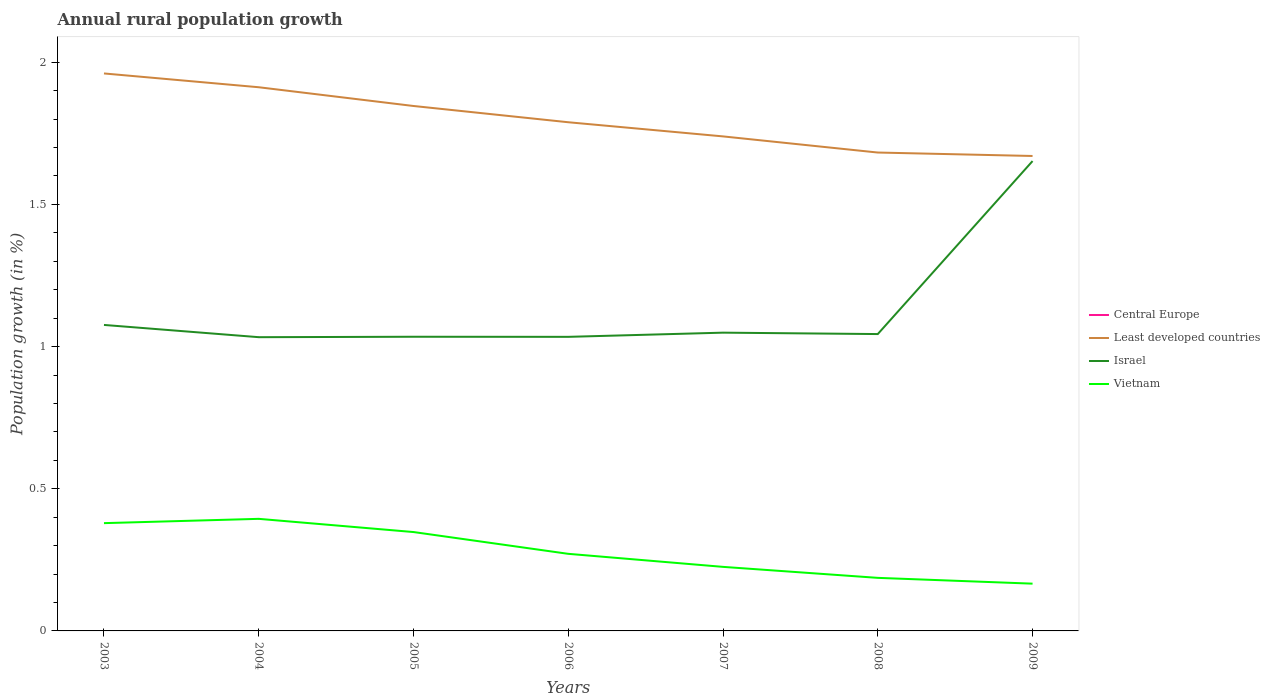Is the number of lines equal to the number of legend labels?
Your answer should be very brief. No. What is the total percentage of rural population growth in Vietnam in the graph?
Your answer should be very brief. 0.08. What is the difference between the highest and the second highest percentage of rural population growth in Israel?
Your answer should be very brief. 0.62. Is the percentage of rural population growth in Israel strictly greater than the percentage of rural population growth in Vietnam over the years?
Make the answer very short. No. How many lines are there?
Give a very brief answer. 3. How many years are there in the graph?
Your answer should be very brief. 7. Does the graph contain any zero values?
Your response must be concise. Yes. Where does the legend appear in the graph?
Your response must be concise. Center right. How are the legend labels stacked?
Provide a succinct answer. Vertical. What is the title of the graph?
Ensure brevity in your answer.  Annual rural population growth. What is the label or title of the X-axis?
Your answer should be compact. Years. What is the label or title of the Y-axis?
Provide a short and direct response. Population growth (in %). What is the Population growth (in %) in Central Europe in 2003?
Keep it short and to the point. 0. What is the Population growth (in %) of Least developed countries in 2003?
Offer a terse response. 1.96. What is the Population growth (in %) of Israel in 2003?
Your answer should be compact. 1.08. What is the Population growth (in %) in Vietnam in 2003?
Ensure brevity in your answer.  0.38. What is the Population growth (in %) in Central Europe in 2004?
Keep it short and to the point. 0. What is the Population growth (in %) of Least developed countries in 2004?
Provide a succinct answer. 1.91. What is the Population growth (in %) of Israel in 2004?
Offer a terse response. 1.03. What is the Population growth (in %) of Vietnam in 2004?
Your answer should be very brief. 0.39. What is the Population growth (in %) of Least developed countries in 2005?
Your answer should be compact. 1.85. What is the Population growth (in %) in Israel in 2005?
Keep it short and to the point. 1.03. What is the Population growth (in %) of Vietnam in 2005?
Provide a short and direct response. 0.35. What is the Population growth (in %) of Least developed countries in 2006?
Give a very brief answer. 1.79. What is the Population growth (in %) of Israel in 2006?
Provide a short and direct response. 1.03. What is the Population growth (in %) of Vietnam in 2006?
Make the answer very short. 0.27. What is the Population growth (in %) of Central Europe in 2007?
Provide a succinct answer. 0. What is the Population growth (in %) in Least developed countries in 2007?
Ensure brevity in your answer.  1.74. What is the Population growth (in %) of Israel in 2007?
Your response must be concise. 1.05. What is the Population growth (in %) of Vietnam in 2007?
Keep it short and to the point. 0.23. What is the Population growth (in %) of Central Europe in 2008?
Provide a short and direct response. 0. What is the Population growth (in %) in Least developed countries in 2008?
Offer a terse response. 1.68. What is the Population growth (in %) in Israel in 2008?
Your answer should be compact. 1.04. What is the Population growth (in %) of Vietnam in 2008?
Provide a succinct answer. 0.19. What is the Population growth (in %) in Least developed countries in 2009?
Offer a terse response. 1.67. What is the Population growth (in %) in Israel in 2009?
Ensure brevity in your answer.  1.65. What is the Population growth (in %) of Vietnam in 2009?
Give a very brief answer. 0.17. Across all years, what is the maximum Population growth (in %) of Least developed countries?
Offer a terse response. 1.96. Across all years, what is the maximum Population growth (in %) of Israel?
Keep it short and to the point. 1.65. Across all years, what is the maximum Population growth (in %) of Vietnam?
Your answer should be very brief. 0.39. Across all years, what is the minimum Population growth (in %) of Least developed countries?
Offer a terse response. 1.67. Across all years, what is the minimum Population growth (in %) in Israel?
Provide a short and direct response. 1.03. Across all years, what is the minimum Population growth (in %) in Vietnam?
Your response must be concise. 0.17. What is the total Population growth (in %) of Central Europe in the graph?
Provide a short and direct response. 0. What is the total Population growth (in %) of Least developed countries in the graph?
Offer a terse response. 12.6. What is the total Population growth (in %) of Israel in the graph?
Offer a very short reply. 7.92. What is the total Population growth (in %) of Vietnam in the graph?
Give a very brief answer. 1.97. What is the difference between the Population growth (in %) in Least developed countries in 2003 and that in 2004?
Give a very brief answer. 0.05. What is the difference between the Population growth (in %) in Israel in 2003 and that in 2004?
Make the answer very short. 0.04. What is the difference between the Population growth (in %) in Vietnam in 2003 and that in 2004?
Ensure brevity in your answer.  -0.02. What is the difference between the Population growth (in %) of Least developed countries in 2003 and that in 2005?
Make the answer very short. 0.11. What is the difference between the Population growth (in %) of Israel in 2003 and that in 2005?
Provide a short and direct response. 0.04. What is the difference between the Population growth (in %) in Vietnam in 2003 and that in 2005?
Give a very brief answer. 0.03. What is the difference between the Population growth (in %) in Least developed countries in 2003 and that in 2006?
Your answer should be very brief. 0.17. What is the difference between the Population growth (in %) of Israel in 2003 and that in 2006?
Your answer should be compact. 0.04. What is the difference between the Population growth (in %) in Vietnam in 2003 and that in 2006?
Keep it short and to the point. 0.11. What is the difference between the Population growth (in %) of Least developed countries in 2003 and that in 2007?
Make the answer very short. 0.22. What is the difference between the Population growth (in %) in Israel in 2003 and that in 2007?
Your answer should be compact. 0.03. What is the difference between the Population growth (in %) in Vietnam in 2003 and that in 2007?
Provide a succinct answer. 0.15. What is the difference between the Population growth (in %) of Least developed countries in 2003 and that in 2008?
Keep it short and to the point. 0.28. What is the difference between the Population growth (in %) of Israel in 2003 and that in 2008?
Provide a short and direct response. 0.03. What is the difference between the Population growth (in %) of Vietnam in 2003 and that in 2008?
Provide a short and direct response. 0.19. What is the difference between the Population growth (in %) of Least developed countries in 2003 and that in 2009?
Keep it short and to the point. 0.29. What is the difference between the Population growth (in %) in Israel in 2003 and that in 2009?
Offer a very short reply. -0.58. What is the difference between the Population growth (in %) of Vietnam in 2003 and that in 2009?
Your answer should be compact. 0.21. What is the difference between the Population growth (in %) in Least developed countries in 2004 and that in 2005?
Your answer should be compact. 0.07. What is the difference between the Population growth (in %) of Israel in 2004 and that in 2005?
Offer a very short reply. -0. What is the difference between the Population growth (in %) of Vietnam in 2004 and that in 2005?
Your response must be concise. 0.05. What is the difference between the Population growth (in %) of Least developed countries in 2004 and that in 2006?
Keep it short and to the point. 0.12. What is the difference between the Population growth (in %) in Israel in 2004 and that in 2006?
Ensure brevity in your answer.  -0. What is the difference between the Population growth (in %) in Vietnam in 2004 and that in 2006?
Your answer should be very brief. 0.12. What is the difference between the Population growth (in %) in Least developed countries in 2004 and that in 2007?
Give a very brief answer. 0.17. What is the difference between the Population growth (in %) of Israel in 2004 and that in 2007?
Provide a short and direct response. -0.02. What is the difference between the Population growth (in %) of Vietnam in 2004 and that in 2007?
Ensure brevity in your answer.  0.17. What is the difference between the Population growth (in %) of Least developed countries in 2004 and that in 2008?
Provide a succinct answer. 0.23. What is the difference between the Population growth (in %) of Israel in 2004 and that in 2008?
Your response must be concise. -0.01. What is the difference between the Population growth (in %) of Vietnam in 2004 and that in 2008?
Keep it short and to the point. 0.21. What is the difference between the Population growth (in %) of Least developed countries in 2004 and that in 2009?
Offer a terse response. 0.24. What is the difference between the Population growth (in %) in Israel in 2004 and that in 2009?
Give a very brief answer. -0.62. What is the difference between the Population growth (in %) in Vietnam in 2004 and that in 2009?
Provide a succinct answer. 0.23. What is the difference between the Population growth (in %) of Least developed countries in 2005 and that in 2006?
Ensure brevity in your answer.  0.06. What is the difference between the Population growth (in %) in Vietnam in 2005 and that in 2006?
Keep it short and to the point. 0.08. What is the difference between the Population growth (in %) of Least developed countries in 2005 and that in 2007?
Provide a succinct answer. 0.11. What is the difference between the Population growth (in %) in Israel in 2005 and that in 2007?
Offer a terse response. -0.01. What is the difference between the Population growth (in %) of Vietnam in 2005 and that in 2007?
Your answer should be very brief. 0.12. What is the difference between the Population growth (in %) in Least developed countries in 2005 and that in 2008?
Your answer should be compact. 0.16. What is the difference between the Population growth (in %) of Israel in 2005 and that in 2008?
Your answer should be compact. -0.01. What is the difference between the Population growth (in %) in Vietnam in 2005 and that in 2008?
Your response must be concise. 0.16. What is the difference between the Population growth (in %) of Least developed countries in 2005 and that in 2009?
Ensure brevity in your answer.  0.18. What is the difference between the Population growth (in %) of Israel in 2005 and that in 2009?
Offer a very short reply. -0.62. What is the difference between the Population growth (in %) in Vietnam in 2005 and that in 2009?
Keep it short and to the point. 0.18. What is the difference between the Population growth (in %) in Least developed countries in 2006 and that in 2007?
Your response must be concise. 0.05. What is the difference between the Population growth (in %) in Israel in 2006 and that in 2007?
Keep it short and to the point. -0.01. What is the difference between the Population growth (in %) of Vietnam in 2006 and that in 2007?
Your answer should be compact. 0.05. What is the difference between the Population growth (in %) of Least developed countries in 2006 and that in 2008?
Ensure brevity in your answer.  0.11. What is the difference between the Population growth (in %) in Israel in 2006 and that in 2008?
Your answer should be very brief. -0.01. What is the difference between the Population growth (in %) in Vietnam in 2006 and that in 2008?
Make the answer very short. 0.08. What is the difference between the Population growth (in %) in Least developed countries in 2006 and that in 2009?
Provide a succinct answer. 0.12. What is the difference between the Population growth (in %) of Israel in 2006 and that in 2009?
Make the answer very short. -0.62. What is the difference between the Population growth (in %) of Vietnam in 2006 and that in 2009?
Keep it short and to the point. 0.1. What is the difference between the Population growth (in %) in Least developed countries in 2007 and that in 2008?
Ensure brevity in your answer.  0.06. What is the difference between the Population growth (in %) of Israel in 2007 and that in 2008?
Provide a succinct answer. 0.01. What is the difference between the Population growth (in %) in Vietnam in 2007 and that in 2008?
Make the answer very short. 0.04. What is the difference between the Population growth (in %) of Least developed countries in 2007 and that in 2009?
Your answer should be very brief. 0.07. What is the difference between the Population growth (in %) in Israel in 2007 and that in 2009?
Your response must be concise. -0.6. What is the difference between the Population growth (in %) in Vietnam in 2007 and that in 2009?
Your answer should be very brief. 0.06. What is the difference between the Population growth (in %) in Least developed countries in 2008 and that in 2009?
Your answer should be very brief. 0.01. What is the difference between the Population growth (in %) of Israel in 2008 and that in 2009?
Your answer should be very brief. -0.61. What is the difference between the Population growth (in %) in Vietnam in 2008 and that in 2009?
Offer a very short reply. 0.02. What is the difference between the Population growth (in %) in Least developed countries in 2003 and the Population growth (in %) in Israel in 2004?
Your answer should be very brief. 0.93. What is the difference between the Population growth (in %) of Least developed countries in 2003 and the Population growth (in %) of Vietnam in 2004?
Give a very brief answer. 1.57. What is the difference between the Population growth (in %) of Israel in 2003 and the Population growth (in %) of Vietnam in 2004?
Your answer should be very brief. 0.68. What is the difference between the Population growth (in %) in Least developed countries in 2003 and the Population growth (in %) in Israel in 2005?
Offer a terse response. 0.93. What is the difference between the Population growth (in %) of Least developed countries in 2003 and the Population growth (in %) of Vietnam in 2005?
Provide a succinct answer. 1.61. What is the difference between the Population growth (in %) of Israel in 2003 and the Population growth (in %) of Vietnam in 2005?
Your answer should be compact. 0.73. What is the difference between the Population growth (in %) of Least developed countries in 2003 and the Population growth (in %) of Israel in 2006?
Make the answer very short. 0.93. What is the difference between the Population growth (in %) in Least developed countries in 2003 and the Population growth (in %) in Vietnam in 2006?
Give a very brief answer. 1.69. What is the difference between the Population growth (in %) in Israel in 2003 and the Population growth (in %) in Vietnam in 2006?
Ensure brevity in your answer.  0.81. What is the difference between the Population growth (in %) in Least developed countries in 2003 and the Population growth (in %) in Israel in 2007?
Offer a terse response. 0.91. What is the difference between the Population growth (in %) of Least developed countries in 2003 and the Population growth (in %) of Vietnam in 2007?
Keep it short and to the point. 1.74. What is the difference between the Population growth (in %) in Israel in 2003 and the Population growth (in %) in Vietnam in 2007?
Provide a short and direct response. 0.85. What is the difference between the Population growth (in %) of Least developed countries in 2003 and the Population growth (in %) of Israel in 2008?
Your answer should be very brief. 0.92. What is the difference between the Population growth (in %) of Least developed countries in 2003 and the Population growth (in %) of Vietnam in 2008?
Your answer should be compact. 1.77. What is the difference between the Population growth (in %) of Israel in 2003 and the Population growth (in %) of Vietnam in 2008?
Give a very brief answer. 0.89. What is the difference between the Population growth (in %) of Least developed countries in 2003 and the Population growth (in %) of Israel in 2009?
Ensure brevity in your answer.  0.31. What is the difference between the Population growth (in %) in Least developed countries in 2003 and the Population growth (in %) in Vietnam in 2009?
Your response must be concise. 1.79. What is the difference between the Population growth (in %) of Israel in 2003 and the Population growth (in %) of Vietnam in 2009?
Offer a very short reply. 0.91. What is the difference between the Population growth (in %) of Least developed countries in 2004 and the Population growth (in %) of Israel in 2005?
Offer a very short reply. 0.88. What is the difference between the Population growth (in %) of Least developed countries in 2004 and the Population growth (in %) of Vietnam in 2005?
Offer a very short reply. 1.56. What is the difference between the Population growth (in %) of Israel in 2004 and the Population growth (in %) of Vietnam in 2005?
Give a very brief answer. 0.69. What is the difference between the Population growth (in %) of Least developed countries in 2004 and the Population growth (in %) of Israel in 2006?
Offer a very short reply. 0.88. What is the difference between the Population growth (in %) in Least developed countries in 2004 and the Population growth (in %) in Vietnam in 2006?
Your answer should be very brief. 1.64. What is the difference between the Population growth (in %) in Israel in 2004 and the Population growth (in %) in Vietnam in 2006?
Keep it short and to the point. 0.76. What is the difference between the Population growth (in %) of Least developed countries in 2004 and the Population growth (in %) of Israel in 2007?
Keep it short and to the point. 0.86. What is the difference between the Population growth (in %) in Least developed countries in 2004 and the Population growth (in %) in Vietnam in 2007?
Offer a terse response. 1.69. What is the difference between the Population growth (in %) in Israel in 2004 and the Population growth (in %) in Vietnam in 2007?
Give a very brief answer. 0.81. What is the difference between the Population growth (in %) in Least developed countries in 2004 and the Population growth (in %) in Israel in 2008?
Offer a very short reply. 0.87. What is the difference between the Population growth (in %) in Least developed countries in 2004 and the Population growth (in %) in Vietnam in 2008?
Give a very brief answer. 1.73. What is the difference between the Population growth (in %) of Israel in 2004 and the Population growth (in %) of Vietnam in 2008?
Offer a terse response. 0.85. What is the difference between the Population growth (in %) in Least developed countries in 2004 and the Population growth (in %) in Israel in 2009?
Ensure brevity in your answer.  0.26. What is the difference between the Population growth (in %) in Least developed countries in 2004 and the Population growth (in %) in Vietnam in 2009?
Your response must be concise. 1.75. What is the difference between the Population growth (in %) in Israel in 2004 and the Population growth (in %) in Vietnam in 2009?
Give a very brief answer. 0.87. What is the difference between the Population growth (in %) in Least developed countries in 2005 and the Population growth (in %) in Israel in 2006?
Ensure brevity in your answer.  0.81. What is the difference between the Population growth (in %) in Least developed countries in 2005 and the Population growth (in %) in Vietnam in 2006?
Your response must be concise. 1.57. What is the difference between the Population growth (in %) of Israel in 2005 and the Population growth (in %) of Vietnam in 2006?
Make the answer very short. 0.76. What is the difference between the Population growth (in %) in Least developed countries in 2005 and the Population growth (in %) in Israel in 2007?
Your answer should be compact. 0.8. What is the difference between the Population growth (in %) of Least developed countries in 2005 and the Population growth (in %) of Vietnam in 2007?
Your answer should be compact. 1.62. What is the difference between the Population growth (in %) in Israel in 2005 and the Population growth (in %) in Vietnam in 2007?
Provide a short and direct response. 0.81. What is the difference between the Population growth (in %) in Least developed countries in 2005 and the Population growth (in %) in Israel in 2008?
Your answer should be very brief. 0.8. What is the difference between the Population growth (in %) in Least developed countries in 2005 and the Population growth (in %) in Vietnam in 2008?
Make the answer very short. 1.66. What is the difference between the Population growth (in %) of Israel in 2005 and the Population growth (in %) of Vietnam in 2008?
Give a very brief answer. 0.85. What is the difference between the Population growth (in %) of Least developed countries in 2005 and the Population growth (in %) of Israel in 2009?
Your answer should be compact. 0.19. What is the difference between the Population growth (in %) in Least developed countries in 2005 and the Population growth (in %) in Vietnam in 2009?
Provide a succinct answer. 1.68. What is the difference between the Population growth (in %) of Israel in 2005 and the Population growth (in %) of Vietnam in 2009?
Your answer should be compact. 0.87. What is the difference between the Population growth (in %) in Least developed countries in 2006 and the Population growth (in %) in Israel in 2007?
Your answer should be very brief. 0.74. What is the difference between the Population growth (in %) of Least developed countries in 2006 and the Population growth (in %) of Vietnam in 2007?
Your answer should be very brief. 1.56. What is the difference between the Population growth (in %) in Israel in 2006 and the Population growth (in %) in Vietnam in 2007?
Your response must be concise. 0.81. What is the difference between the Population growth (in %) of Least developed countries in 2006 and the Population growth (in %) of Israel in 2008?
Provide a succinct answer. 0.74. What is the difference between the Population growth (in %) of Least developed countries in 2006 and the Population growth (in %) of Vietnam in 2008?
Your answer should be very brief. 1.6. What is the difference between the Population growth (in %) in Israel in 2006 and the Population growth (in %) in Vietnam in 2008?
Your answer should be compact. 0.85. What is the difference between the Population growth (in %) in Least developed countries in 2006 and the Population growth (in %) in Israel in 2009?
Your answer should be compact. 0.14. What is the difference between the Population growth (in %) in Least developed countries in 2006 and the Population growth (in %) in Vietnam in 2009?
Make the answer very short. 1.62. What is the difference between the Population growth (in %) of Israel in 2006 and the Population growth (in %) of Vietnam in 2009?
Give a very brief answer. 0.87. What is the difference between the Population growth (in %) in Least developed countries in 2007 and the Population growth (in %) in Israel in 2008?
Your answer should be very brief. 0.7. What is the difference between the Population growth (in %) of Least developed countries in 2007 and the Population growth (in %) of Vietnam in 2008?
Ensure brevity in your answer.  1.55. What is the difference between the Population growth (in %) of Israel in 2007 and the Population growth (in %) of Vietnam in 2008?
Provide a succinct answer. 0.86. What is the difference between the Population growth (in %) of Least developed countries in 2007 and the Population growth (in %) of Israel in 2009?
Provide a succinct answer. 0.09. What is the difference between the Population growth (in %) in Least developed countries in 2007 and the Population growth (in %) in Vietnam in 2009?
Offer a terse response. 1.57. What is the difference between the Population growth (in %) of Israel in 2007 and the Population growth (in %) of Vietnam in 2009?
Your answer should be compact. 0.88. What is the difference between the Population growth (in %) of Least developed countries in 2008 and the Population growth (in %) of Israel in 2009?
Ensure brevity in your answer.  0.03. What is the difference between the Population growth (in %) of Least developed countries in 2008 and the Population growth (in %) of Vietnam in 2009?
Make the answer very short. 1.52. What is the difference between the Population growth (in %) of Israel in 2008 and the Population growth (in %) of Vietnam in 2009?
Your response must be concise. 0.88. What is the average Population growth (in %) of Israel per year?
Provide a short and direct response. 1.13. What is the average Population growth (in %) of Vietnam per year?
Ensure brevity in your answer.  0.28. In the year 2003, what is the difference between the Population growth (in %) in Least developed countries and Population growth (in %) in Israel?
Offer a very short reply. 0.88. In the year 2003, what is the difference between the Population growth (in %) in Least developed countries and Population growth (in %) in Vietnam?
Give a very brief answer. 1.58. In the year 2003, what is the difference between the Population growth (in %) of Israel and Population growth (in %) of Vietnam?
Your answer should be very brief. 0.7. In the year 2004, what is the difference between the Population growth (in %) in Least developed countries and Population growth (in %) in Israel?
Keep it short and to the point. 0.88. In the year 2004, what is the difference between the Population growth (in %) in Least developed countries and Population growth (in %) in Vietnam?
Your answer should be compact. 1.52. In the year 2004, what is the difference between the Population growth (in %) in Israel and Population growth (in %) in Vietnam?
Your response must be concise. 0.64. In the year 2005, what is the difference between the Population growth (in %) in Least developed countries and Population growth (in %) in Israel?
Give a very brief answer. 0.81. In the year 2005, what is the difference between the Population growth (in %) of Least developed countries and Population growth (in %) of Vietnam?
Offer a terse response. 1.5. In the year 2005, what is the difference between the Population growth (in %) of Israel and Population growth (in %) of Vietnam?
Keep it short and to the point. 0.69. In the year 2006, what is the difference between the Population growth (in %) in Least developed countries and Population growth (in %) in Israel?
Give a very brief answer. 0.75. In the year 2006, what is the difference between the Population growth (in %) of Least developed countries and Population growth (in %) of Vietnam?
Offer a terse response. 1.52. In the year 2006, what is the difference between the Population growth (in %) of Israel and Population growth (in %) of Vietnam?
Provide a succinct answer. 0.76. In the year 2007, what is the difference between the Population growth (in %) in Least developed countries and Population growth (in %) in Israel?
Make the answer very short. 0.69. In the year 2007, what is the difference between the Population growth (in %) of Least developed countries and Population growth (in %) of Vietnam?
Provide a succinct answer. 1.51. In the year 2007, what is the difference between the Population growth (in %) in Israel and Population growth (in %) in Vietnam?
Ensure brevity in your answer.  0.82. In the year 2008, what is the difference between the Population growth (in %) of Least developed countries and Population growth (in %) of Israel?
Provide a succinct answer. 0.64. In the year 2008, what is the difference between the Population growth (in %) of Least developed countries and Population growth (in %) of Vietnam?
Your response must be concise. 1.5. In the year 2008, what is the difference between the Population growth (in %) of Israel and Population growth (in %) of Vietnam?
Ensure brevity in your answer.  0.86. In the year 2009, what is the difference between the Population growth (in %) of Least developed countries and Population growth (in %) of Israel?
Your answer should be very brief. 0.02. In the year 2009, what is the difference between the Population growth (in %) in Least developed countries and Population growth (in %) in Vietnam?
Ensure brevity in your answer.  1.5. In the year 2009, what is the difference between the Population growth (in %) of Israel and Population growth (in %) of Vietnam?
Your answer should be compact. 1.49. What is the ratio of the Population growth (in %) of Least developed countries in 2003 to that in 2004?
Make the answer very short. 1.03. What is the ratio of the Population growth (in %) in Israel in 2003 to that in 2004?
Your answer should be very brief. 1.04. What is the ratio of the Population growth (in %) in Vietnam in 2003 to that in 2004?
Keep it short and to the point. 0.96. What is the ratio of the Population growth (in %) in Least developed countries in 2003 to that in 2005?
Ensure brevity in your answer.  1.06. What is the ratio of the Population growth (in %) in Israel in 2003 to that in 2005?
Your response must be concise. 1.04. What is the ratio of the Population growth (in %) of Vietnam in 2003 to that in 2005?
Your response must be concise. 1.09. What is the ratio of the Population growth (in %) in Least developed countries in 2003 to that in 2006?
Make the answer very short. 1.1. What is the ratio of the Population growth (in %) in Israel in 2003 to that in 2006?
Your answer should be very brief. 1.04. What is the ratio of the Population growth (in %) in Vietnam in 2003 to that in 2006?
Your answer should be compact. 1.4. What is the ratio of the Population growth (in %) in Least developed countries in 2003 to that in 2007?
Keep it short and to the point. 1.13. What is the ratio of the Population growth (in %) in Israel in 2003 to that in 2007?
Keep it short and to the point. 1.03. What is the ratio of the Population growth (in %) in Vietnam in 2003 to that in 2007?
Offer a terse response. 1.68. What is the ratio of the Population growth (in %) in Least developed countries in 2003 to that in 2008?
Your response must be concise. 1.17. What is the ratio of the Population growth (in %) in Israel in 2003 to that in 2008?
Provide a short and direct response. 1.03. What is the ratio of the Population growth (in %) of Vietnam in 2003 to that in 2008?
Give a very brief answer. 2.03. What is the ratio of the Population growth (in %) of Least developed countries in 2003 to that in 2009?
Your response must be concise. 1.17. What is the ratio of the Population growth (in %) in Israel in 2003 to that in 2009?
Your answer should be compact. 0.65. What is the ratio of the Population growth (in %) in Vietnam in 2003 to that in 2009?
Your answer should be compact. 2.28. What is the ratio of the Population growth (in %) of Least developed countries in 2004 to that in 2005?
Your answer should be very brief. 1.04. What is the ratio of the Population growth (in %) of Israel in 2004 to that in 2005?
Give a very brief answer. 1. What is the ratio of the Population growth (in %) in Vietnam in 2004 to that in 2005?
Give a very brief answer. 1.13. What is the ratio of the Population growth (in %) in Least developed countries in 2004 to that in 2006?
Ensure brevity in your answer.  1.07. What is the ratio of the Population growth (in %) in Vietnam in 2004 to that in 2006?
Your answer should be very brief. 1.45. What is the ratio of the Population growth (in %) of Least developed countries in 2004 to that in 2007?
Keep it short and to the point. 1.1. What is the ratio of the Population growth (in %) of Vietnam in 2004 to that in 2007?
Your response must be concise. 1.75. What is the ratio of the Population growth (in %) in Least developed countries in 2004 to that in 2008?
Ensure brevity in your answer.  1.14. What is the ratio of the Population growth (in %) of Israel in 2004 to that in 2008?
Your response must be concise. 0.99. What is the ratio of the Population growth (in %) in Vietnam in 2004 to that in 2008?
Make the answer very short. 2.11. What is the ratio of the Population growth (in %) in Least developed countries in 2004 to that in 2009?
Make the answer very short. 1.14. What is the ratio of the Population growth (in %) of Israel in 2004 to that in 2009?
Your answer should be compact. 0.63. What is the ratio of the Population growth (in %) in Vietnam in 2004 to that in 2009?
Give a very brief answer. 2.37. What is the ratio of the Population growth (in %) of Least developed countries in 2005 to that in 2006?
Offer a terse response. 1.03. What is the ratio of the Population growth (in %) in Israel in 2005 to that in 2006?
Give a very brief answer. 1. What is the ratio of the Population growth (in %) of Vietnam in 2005 to that in 2006?
Provide a short and direct response. 1.28. What is the ratio of the Population growth (in %) of Least developed countries in 2005 to that in 2007?
Your response must be concise. 1.06. What is the ratio of the Population growth (in %) of Israel in 2005 to that in 2007?
Keep it short and to the point. 0.99. What is the ratio of the Population growth (in %) in Vietnam in 2005 to that in 2007?
Your answer should be compact. 1.54. What is the ratio of the Population growth (in %) in Least developed countries in 2005 to that in 2008?
Offer a terse response. 1.1. What is the ratio of the Population growth (in %) in Israel in 2005 to that in 2008?
Your answer should be compact. 0.99. What is the ratio of the Population growth (in %) in Vietnam in 2005 to that in 2008?
Keep it short and to the point. 1.86. What is the ratio of the Population growth (in %) in Least developed countries in 2005 to that in 2009?
Offer a terse response. 1.11. What is the ratio of the Population growth (in %) in Israel in 2005 to that in 2009?
Your answer should be compact. 0.63. What is the ratio of the Population growth (in %) in Vietnam in 2005 to that in 2009?
Your answer should be compact. 2.09. What is the ratio of the Population growth (in %) in Least developed countries in 2006 to that in 2007?
Offer a terse response. 1.03. What is the ratio of the Population growth (in %) of Israel in 2006 to that in 2007?
Your answer should be compact. 0.99. What is the ratio of the Population growth (in %) in Vietnam in 2006 to that in 2007?
Give a very brief answer. 1.2. What is the ratio of the Population growth (in %) of Least developed countries in 2006 to that in 2008?
Provide a short and direct response. 1.06. What is the ratio of the Population growth (in %) in Israel in 2006 to that in 2008?
Your answer should be very brief. 0.99. What is the ratio of the Population growth (in %) in Vietnam in 2006 to that in 2008?
Provide a short and direct response. 1.45. What is the ratio of the Population growth (in %) of Least developed countries in 2006 to that in 2009?
Give a very brief answer. 1.07. What is the ratio of the Population growth (in %) in Israel in 2006 to that in 2009?
Offer a terse response. 0.63. What is the ratio of the Population growth (in %) in Vietnam in 2006 to that in 2009?
Give a very brief answer. 1.63. What is the ratio of the Population growth (in %) in Least developed countries in 2007 to that in 2008?
Make the answer very short. 1.03. What is the ratio of the Population growth (in %) of Vietnam in 2007 to that in 2008?
Your answer should be compact. 1.21. What is the ratio of the Population growth (in %) in Least developed countries in 2007 to that in 2009?
Provide a short and direct response. 1.04. What is the ratio of the Population growth (in %) of Israel in 2007 to that in 2009?
Your response must be concise. 0.63. What is the ratio of the Population growth (in %) of Vietnam in 2007 to that in 2009?
Your answer should be compact. 1.36. What is the ratio of the Population growth (in %) of Least developed countries in 2008 to that in 2009?
Keep it short and to the point. 1.01. What is the ratio of the Population growth (in %) in Israel in 2008 to that in 2009?
Your answer should be compact. 0.63. What is the ratio of the Population growth (in %) in Vietnam in 2008 to that in 2009?
Keep it short and to the point. 1.12. What is the difference between the highest and the second highest Population growth (in %) of Least developed countries?
Provide a short and direct response. 0.05. What is the difference between the highest and the second highest Population growth (in %) in Israel?
Offer a very short reply. 0.58. What is the difference between the highest and the second highest Population growth (in %) of Vietnam?
Give a very brief answer. 0.02. What is the difference between the highest and the lowest Population growth (in %) in Least developed countries?
Give a very brief answer. 0.29. What is the difference between the highest and the lowest Population growth (in %) of Israel?
Your response must be concise. 0.62. What is the difference between the highest and the lowest Population growth (in %) in Vietnam?
Offer a terse response. 0.23. 